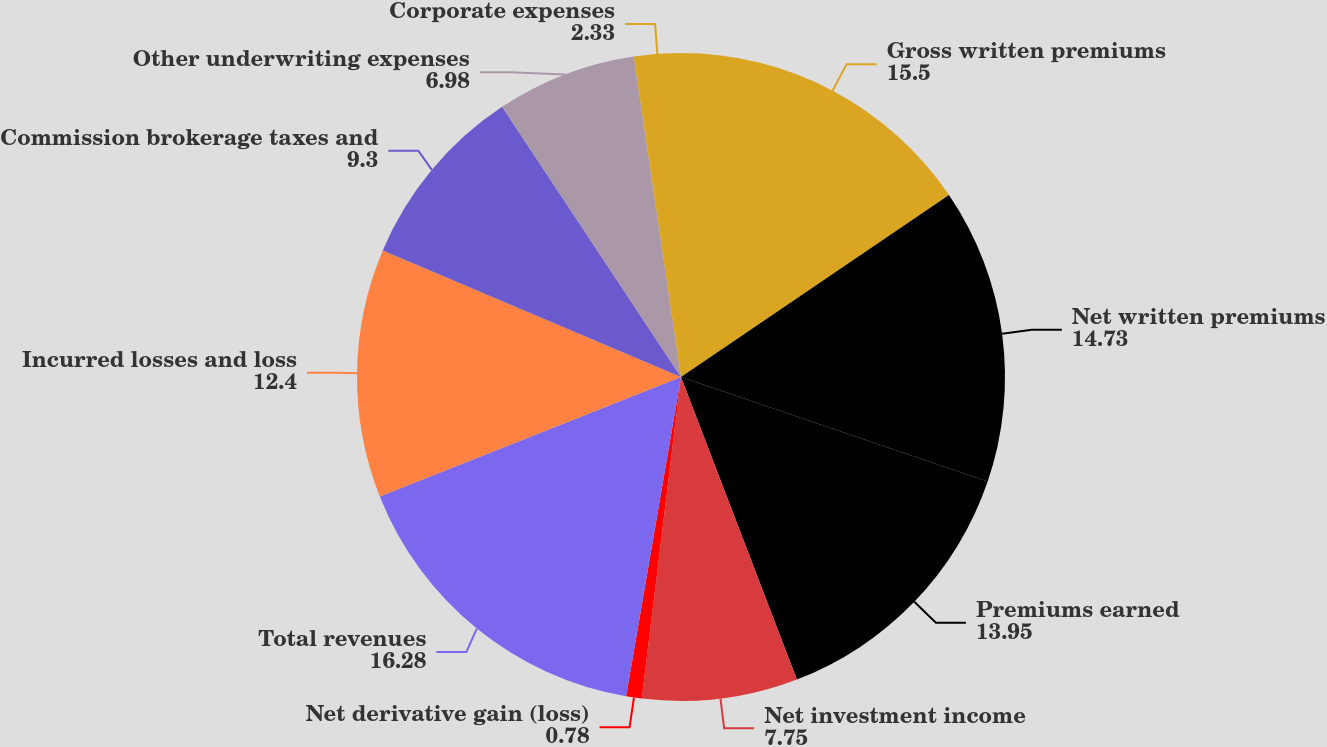Convert chart to OTSL. <chart><loc_0><loc_0><loc_500><loc_500><pie_chart><fcel>Gross written premiums<fcel>Net written premiums<fcel>Premiums earned<fcel>Net investment income<fcel>Net derivative gain (loss)<fcel>Total revenues<fcel>Incurred losses and loss<fcel>Commission brokerage taxes and<fcel>Other underwriting expenses<fcel>Corporate expenses<nl><fcel>15.5%<fcel>14.73%<fcel>13.95%<fcel>7.75%<fcel>0.78%<fcel>16.28%<fcel>12.4%<fcel>9.3%<fcel>6.98%<fcel>2.33%<nl></chart> 